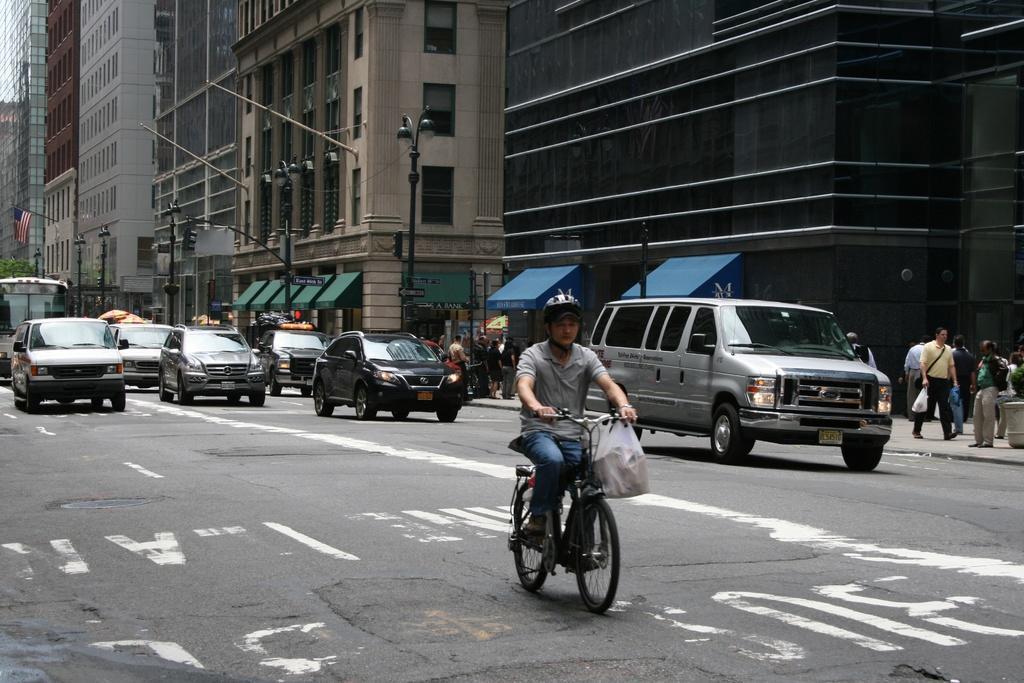Describe this image in one or two sentences. a person is riding a bicycle on the road there are many cars on the road,there are many pedestrians walking on the footpath there are many buildings near to the road. 